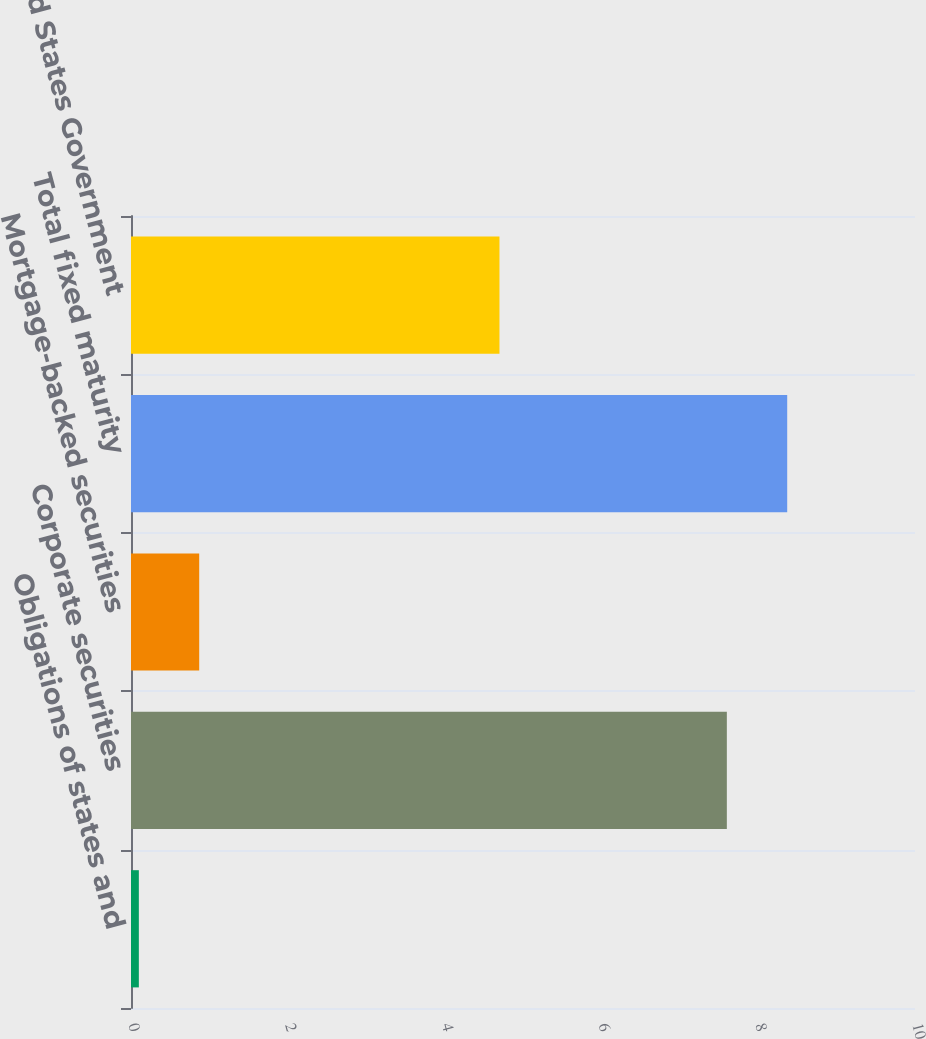Convert chart to OTSL. <chart><loc_0><loc_0><loc_500><loc_500><bar_chart><fcel>Obligations of states and<fcel>Corporate securities<fcel>Mortgage-backed securities<fcel>Total fixed maturity<fcel>United States Government<nl><fcel>0.1<fcel>7.6<fcel>0.87<fcel>8.37<fcel>4.7<nl></chart> 